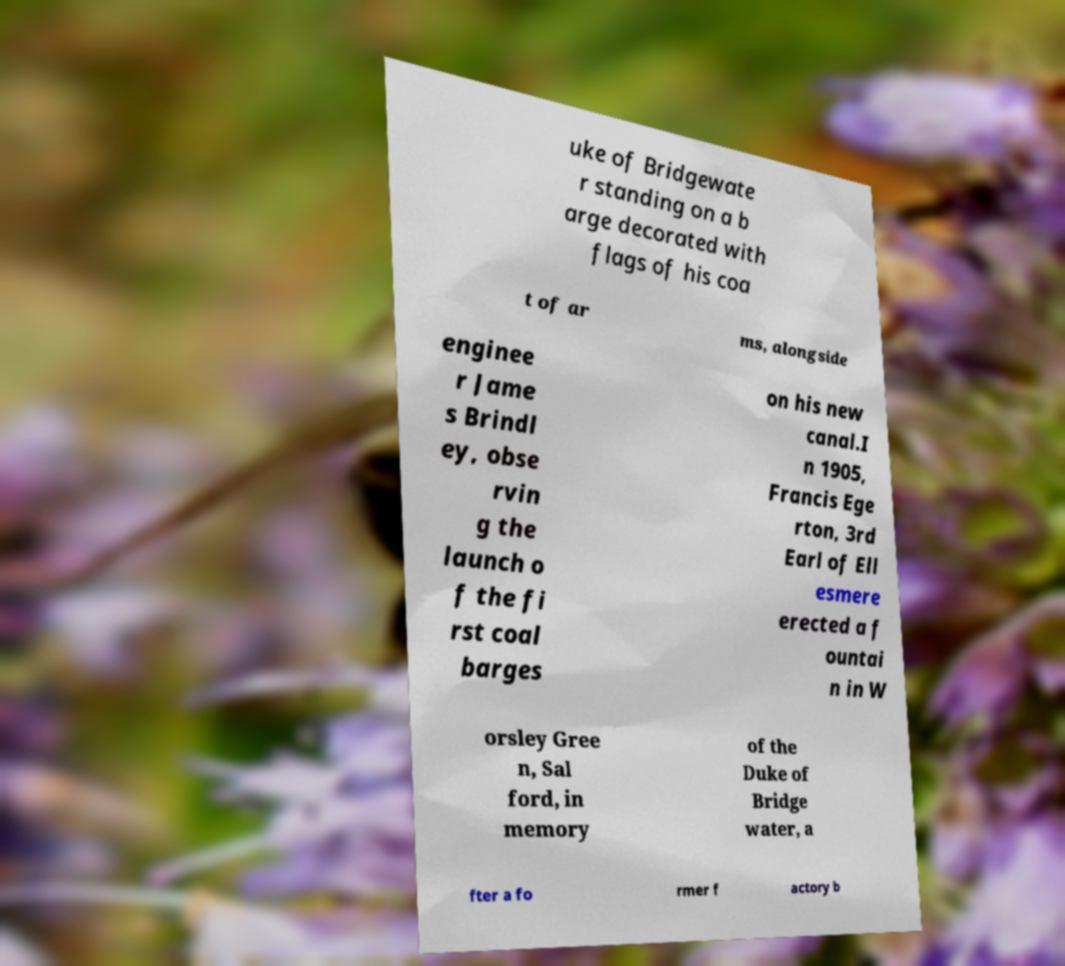There's text embedded in this image that I need extracted. Can you transcribe it verbatim? uke of Bridgewate r standing on a b arge decorated with flags of his coa t of ar ms, alongside enginee r Jame s Brindl ey, obse rvin g the launch o f the fi rst coal barges on his new canal.I n 1905, Francis Ege rton, 3rd Earl of Ell esmere erected a f ountai n in W orsley Gree n, Sal ford, in memory of the Duke of Bridge water, a fter a fo rmer f actory b 